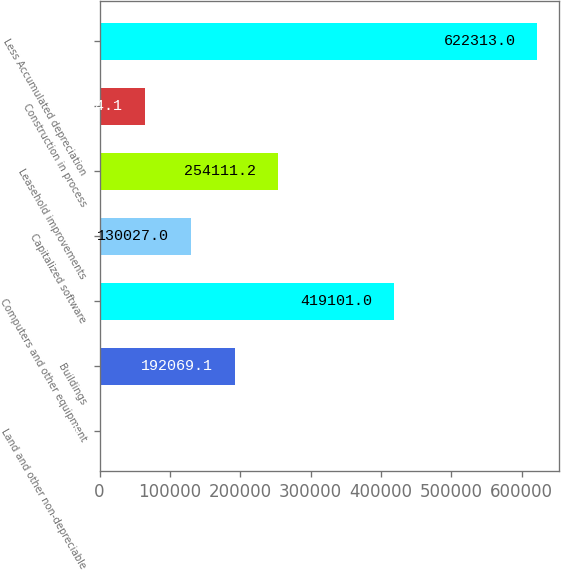Convert chart. <chart><loc_0><loc_0><loc_500><loc_500><bar_chart><fcel>Land and other non-depreciable<fcel>Buildings<fcel>Computers and other equipment<fcel>Capitalized software<fcel>Leasehold improvements<fcel>Construction in process<fcel>Less Accumulated depreciation<nl><fcel>1892<fcel>192069<fcel>419101<fcel>130027<fcel>254111<fcel>63934.1<fcel>622313<nl></chart> 